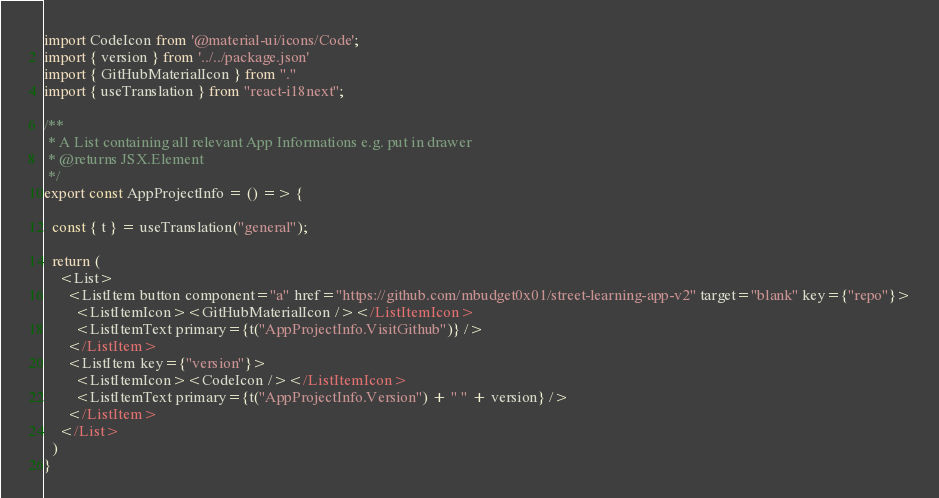Convert code to text. <code><loc_0><loc_0><loc_500><loc_500><_TypeScript_>import CodeIcon from '@material-ui/icons/Code';
import { version } from '../../package.json'
import { GitHubMaterialIcon } from "."
import { useTranslation } from "react-i18next";

/**
 * A List containing all relevant App Informations e.g. put in drawer
 * @returns JSX.Element
 */
export const AppProjectInfo = () => {

  const { t } = useTranslation("general");

  return (
    <List>
      <ListItem button component="a" href="https://github.com/mbudget0x01/street-learning-app-v2" target="blank" key={"repo"}>
        <ListItemIcon><GitHubMaterialIcon /></ListItemIcon>
        <ListItemText primary={t("AppProjectInfo.VisitGithub")} />
      </ListItem>
      <ListItem key={"version"}>
        <ListItemIcon><CodeIcon /></ListItemIcon>
        <ListItemText primary={t("AppProjectInfo.Version") + " " + version} />
      </ListItem>
    </List>
  )
}</code> 